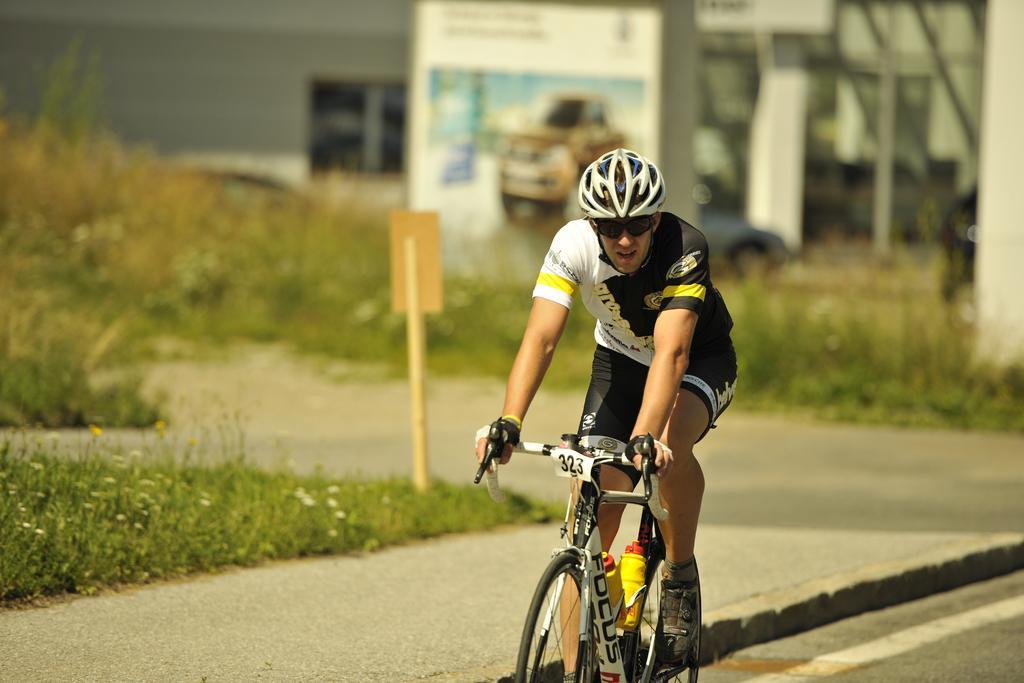Can you describe this image briefly? In this image we can see a person riding a bicycle on the road, there are some plants, also we can see a pole with a board, vehicle and a poster with some text and image, in the background we can see a building. 